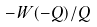<formula> <loc_0><loc_0><loc_500><loc_500>- W ( - Q ) / Q</formula> 